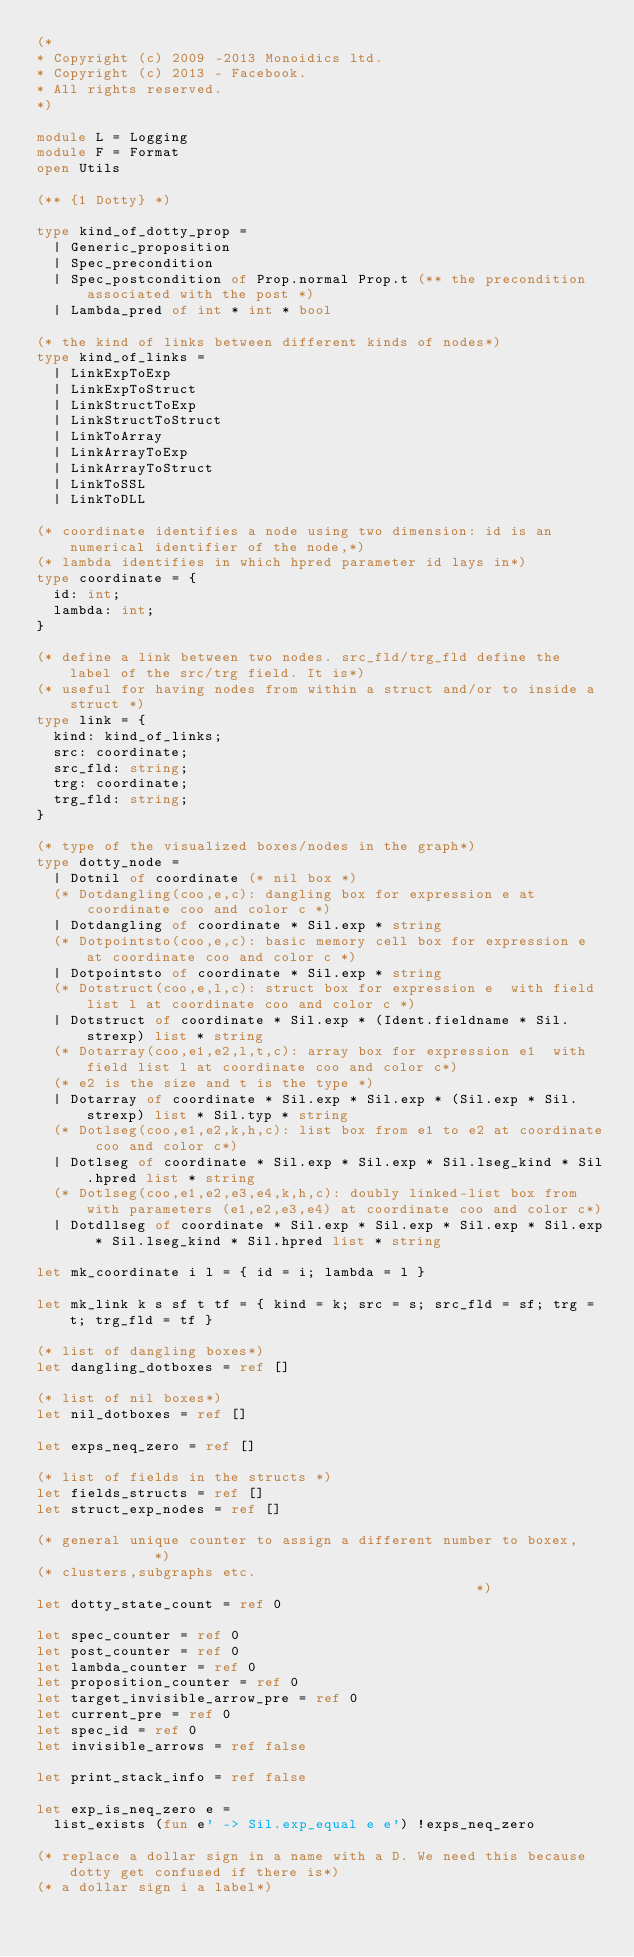<code> <loc_0><loc_0><loc_500><loc_500><_OCaml_>(*
* Copyright (c) 2009 -2013 Monoidics ltd.
* Copyright (c) 2013 - Facebook.
* All rights reserved.
*)

module L = Logging
module F = Format
open Utils

(** {1 Dotty} *)

type kind_of_dotty_prop =
  | Generic_proposition
  | Spec_precondition
  | Spec_postcondition of Prop.normal Prop.t (** the precondition associated with the post *)
  | Lambda_pred of int * int * bool

(* the kind of links between different kinds of nodes*)
type kind_of_links =
  | LinkExpToExp
  | LinkExpToStruct
  | LinkStructToExp
  | LinkStructToStruct
  | LinkToArray
  | LinkArrayToExp
  | LinkArrayToStruct
  | LinkToSSL
  | LinkToDLL

(* coordinate identifies a node using two dimension: id is an numerical identifier of the node,*)
(* lambda identifies in which hpred parameter id lays in*)
type coordinate = {
  id: int;
  lambda: int;
}

(* define a link between two nodes. src_fld/trg_fld define the label of the src/trg field. It is*)
(* useful for having nodes from within a struct and/or to inside a struct *)
type link = {
  kind: kind_of_links;
  src: coordinate;
  src_fld: string;
  trg: coordinate;
  trg_fld: string;
}

(* type of the visualized boxes/nodes in the graph*)
type dotty_node =
  | Dotnil of coordinate (* nil box *)
  (* Dotdangling(coo,e,c): dangling box for expression e at coordinate coo and color c *)
  | Dotdangling of coordinate * Sil.exp * string
  (* Dotpointsto(coo,e,c): basic memory cell box for expression e at coordinate coo and color c *)
  | Dotpointsto of coordinate * Sil.exp * string
  (* Dotstruct(coo,e,l,c): struct box for expression e  with field list l at coordinate coo and color c *)
  | Dotstruct of coordinate * Sil.exp * (Ident.fieldname * Sil.strexp) list * string
  (* Dotarray(coo,e1,e2,l,t,c): array box for expression e1  with field list l at coordinate coo and color c*)
  (* e2 is the size and t is the type *)
  | Dotarray of coordinate * Sil.exp * Sil.exp * (Sil.exp * Sil.strexp) list * Sil.typ * string
  (* Dotlseg(coo,e1,e2,k,h,c): list box from e1 to e2 at coordinate coo and color c*)
  | Dotlseg of coordinate * Sil.exp * Sil.exp * Sil.lseg_kind * Sil.hpred list * string
  (* Dotlseg(coo,e1,e2,e3,e4,k,h,c): doubly linked-list box from with parameters (e1,e2,e3,e4) at coordinate coo and color c*)
  | Dotdllseg of coordinate * Sil.exp * Sil.exp * Sil.exp * Sil.exp * Sil.lseg_kind * Sil.hpred list * string

let mk_coordinate i l = { id = i; lambda = l }

let mk_link k s sf t tf = { kind = k; src = s; src_fld = sf; trg = t; trg_fld = tf }

(* list of dangling boxes*)
let dangling_dotboxes = ref []

(* list of nil boxes*)
let nil_dotboxes = ref []

let exps_neq_zero = ref []

(* list of fields in the structs *)
let fields_structs = ref []
let struct_exp_nodes = ref []

(* general unique counter to assign a different number to boxex,           *)
(* clusters,subgraphs etc.                                                 *)
let dotty_state_count = ref 0

let spec_counter = ref 0
let post_counter = ref 0
let lambda_counter = ref 0
let proposition_counter = ref 0
let target_invisible_arrow_pre = ref 0
let current_pre = ref 0
let spec_id = ref 0
let invisible_arrows = ref false

let print_stack_info = ref false

let exp_is_neq_zero e =
  list_exists (fun e' -> Sil.exp_equal e e') !exps_neq_zero

(* replace a dollar sign in a name with a D. We need this because dotty get confused if there is*)
(* a dollar sign i a label*)</code> 